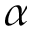Convert formula to latex. <formula><loc_0><loc_0><loc_500><loc_500>\alpha</formula> 